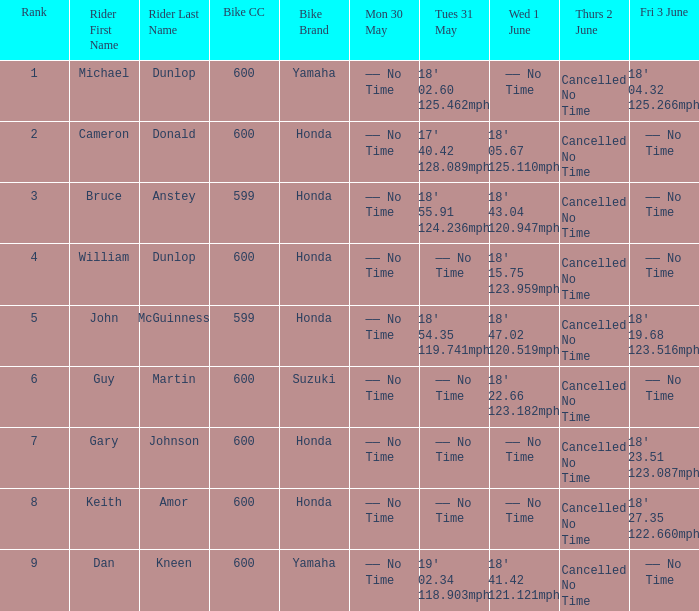What is the rank of the rider whose Tues 31 May time was 19' 02.34 118.903mph? 9.0. 